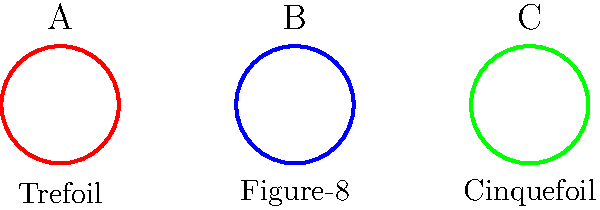Which of the knots shown above has a Jones polynomial of $V(t) = t^2 - t + 1 - t^{-1} + t^{-2}$, and what is its crossing number? To answer this question, we need to analyze the Jones polynomials and crossing numbers of the given knots:

1. Knot A (Trefoil):
   - Jones polynomial: $V(t) = t + t^3 - t^4$
   - Crossing number: 3

2. Knot B (Figure-8):
   - Jones polynomial: $V(t) = t^2 - t + 1 - t^{-1} + t^{-2}$
   - Crossing number: 4

3. Knot C (Cinquefoil):
   - Jones polynomial: $V(t) = t^2 + t^4 - t^5 + t^6 - t^7$
   - Crossing number: 5

Comparing the given Jones polynomial $V(t) = t^2 - t + 1 - t^{-1} + t^{-2}$ with the polynomials of the three knots, we can see that it matches the Jones polynomial of Knot B, the Figure-8 knot.

The crossing number of the Figure-8 knot is 4, which represents the minimum number of crossings in any diagram of the knot.
Answer: Figure-8 knot (B), crossing number 4 